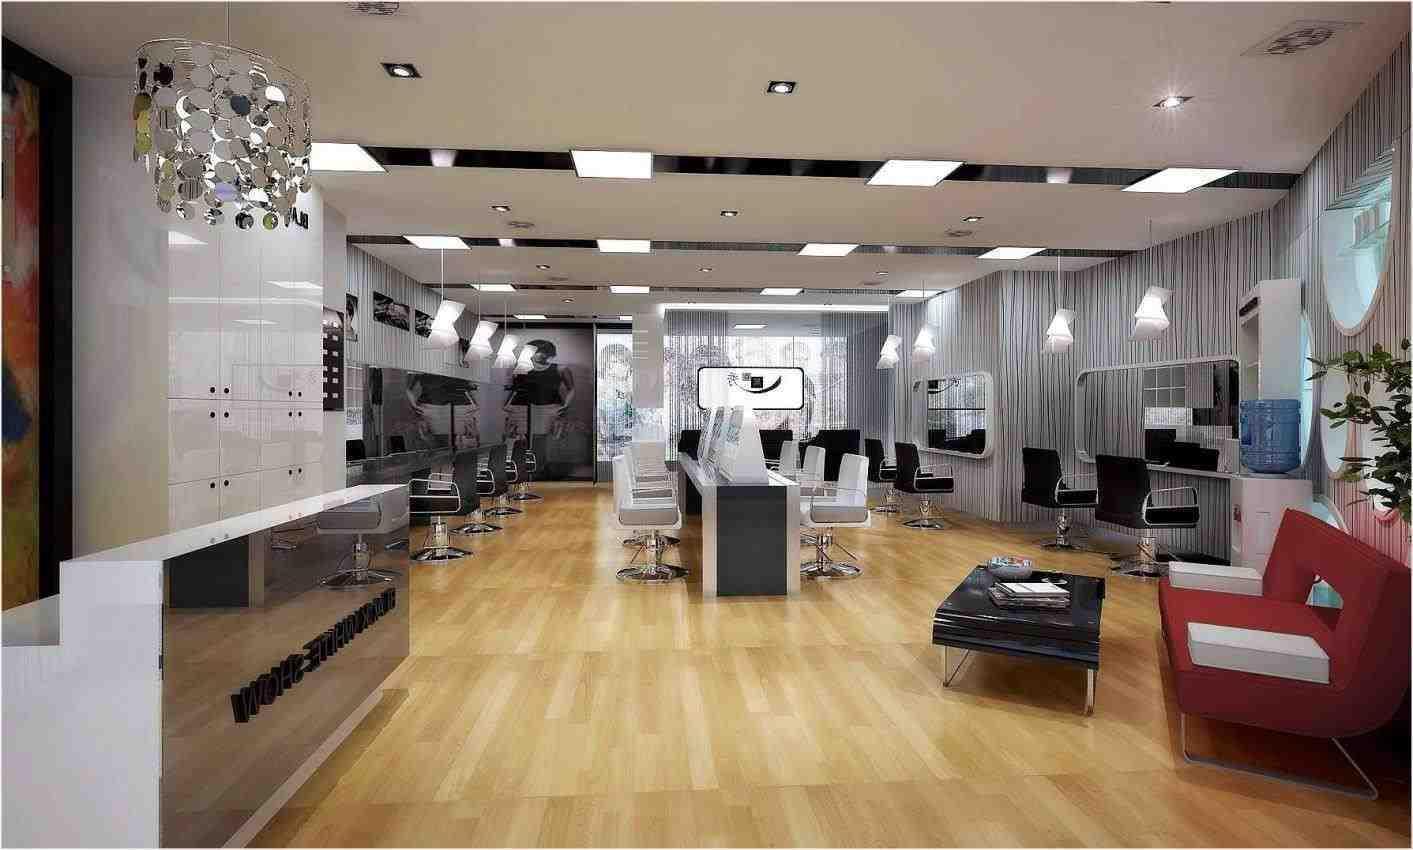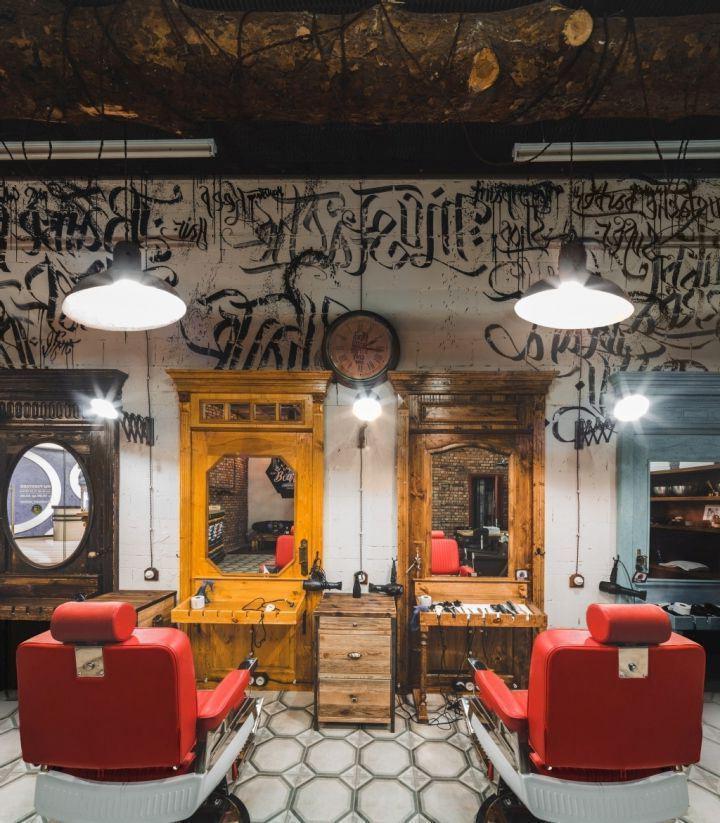The first image is the image on the left, the second image is the image on the right. Given the left and right images, does the statement "At least one image shows the front side of a barber chair." hold true? Answer yes or no. No. The first image is the image on the left, the second image is the image on the right. For the images shown, is this caption "A row of five black barber chairs faces the camera in one image." true? Answer yes or no. No. 